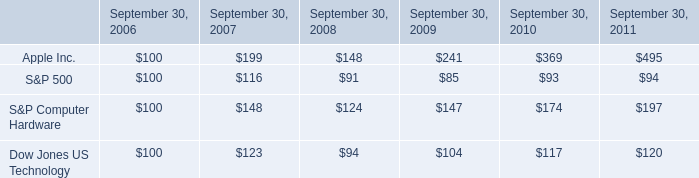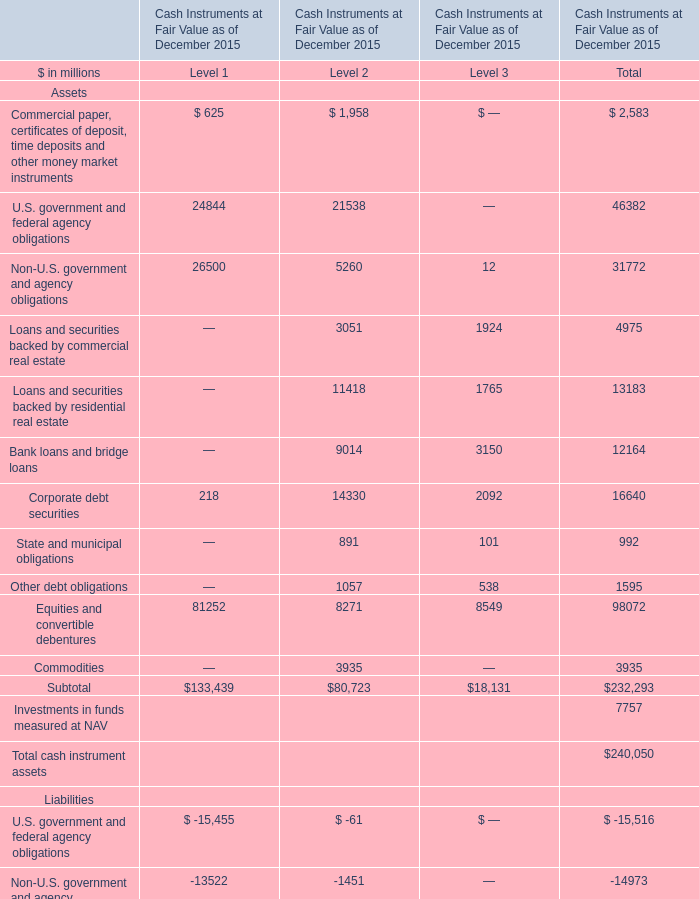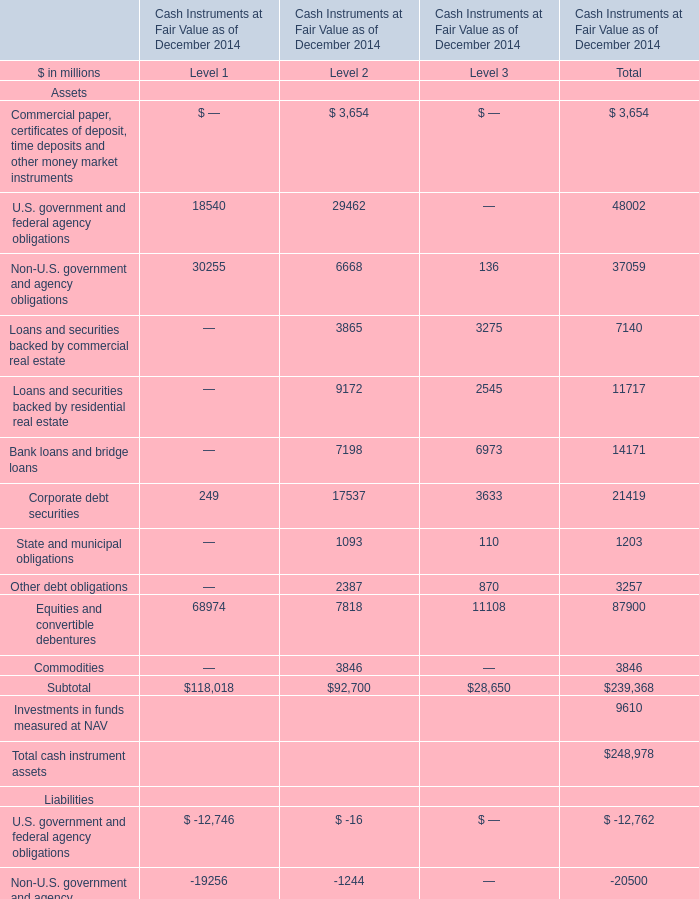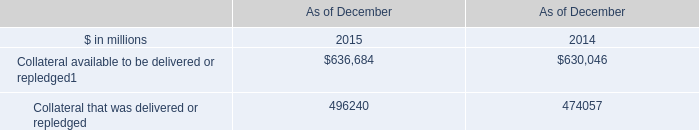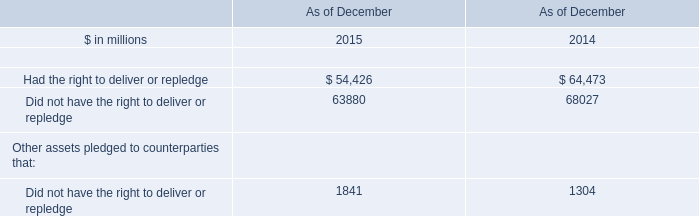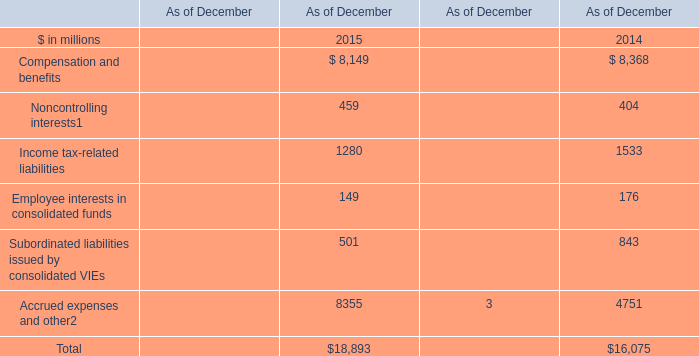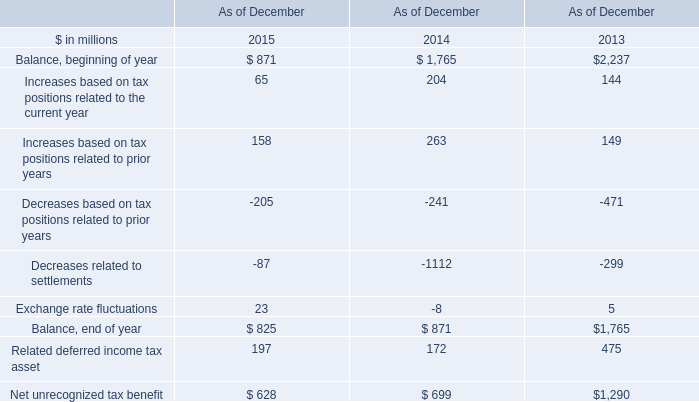what is the highest total amount of Equities and convertible debentures of Assets? (in million) 
Answer: 68974. 